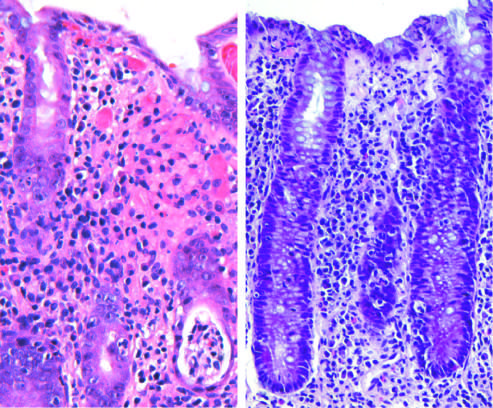s a crypt abscess present in the lower right?
Answer the question using a single word or phrase. Yes 